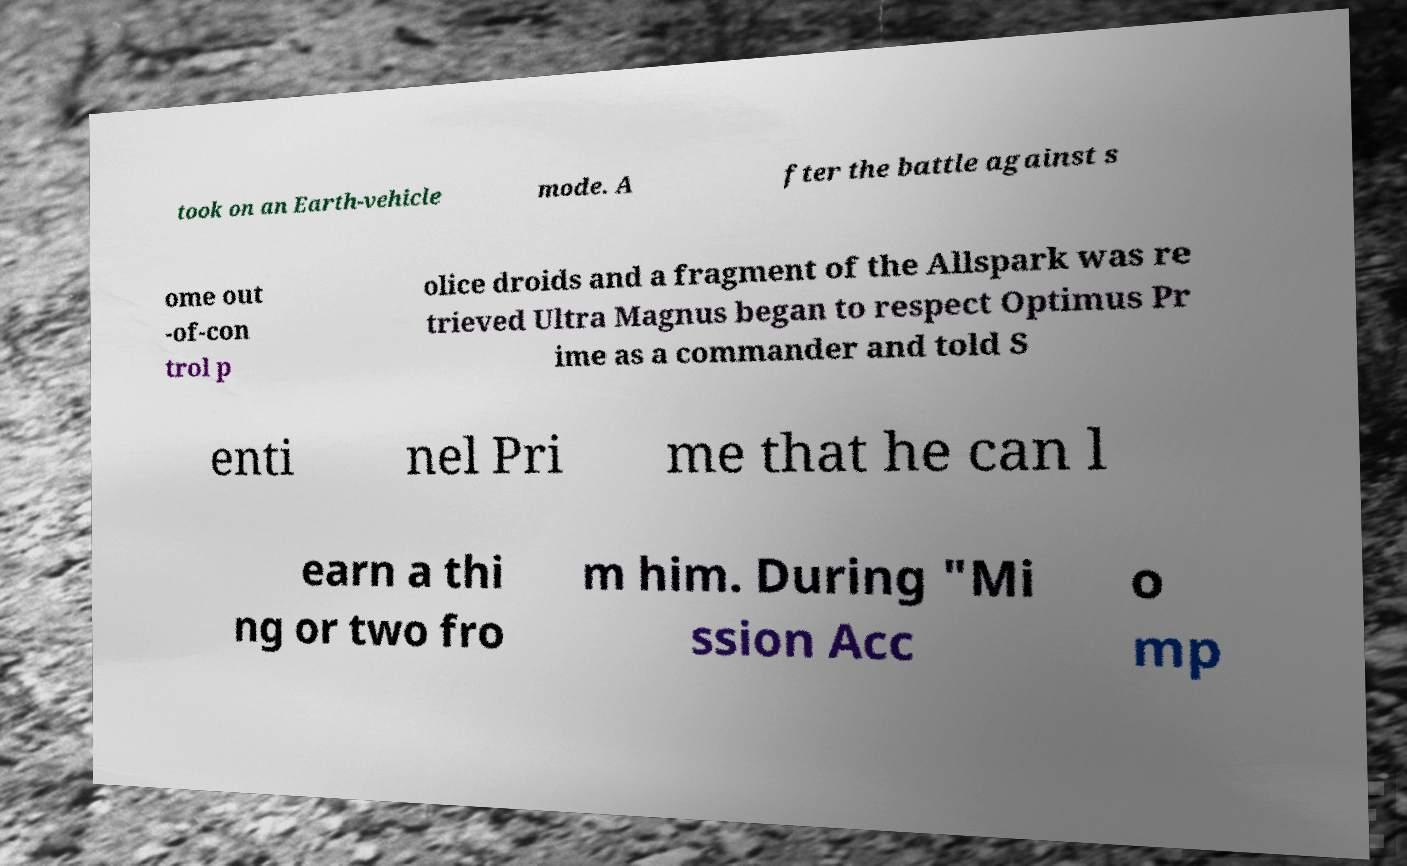Could you extract and type out the text from this image? took on an Earth-vehicle mode. A fter the battle against s ome out -of-con trol p olice droids and a fragment of the Allspark was re trieved Ultra Magnus began to respect Optimus Pr ime as a commander and told S enti nel Pri me that he can l earn a thi ng or two fro m him. During "Mi ssion Acc o mp 